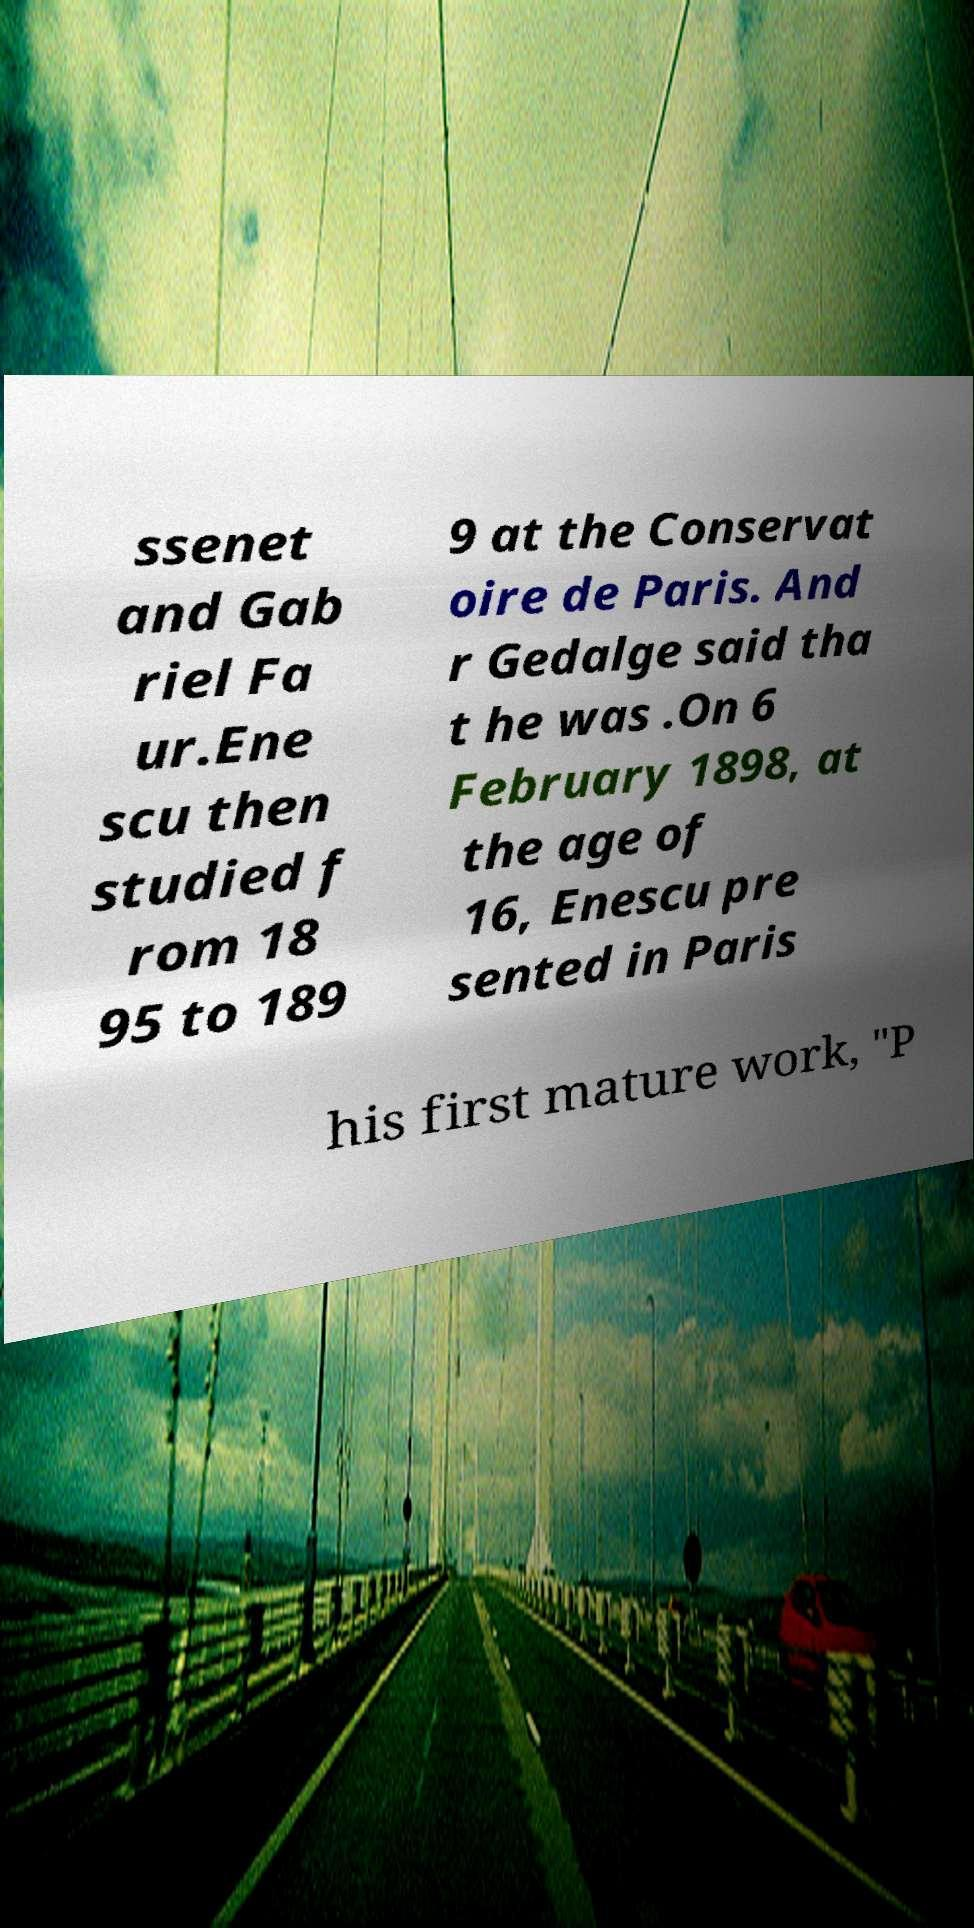For documentation purposes, I need the text within this image transcribed. Could you provide that? ssenet and Gab riel Fa ur.Ene scu then studied f rom 18 95 to 189 9 at the Conservat oire de Paris. And r Gedalge said tha t he was .On 6 February 1898, at the age of 16, Enescu pre sented in Paris his first mature work, "P 